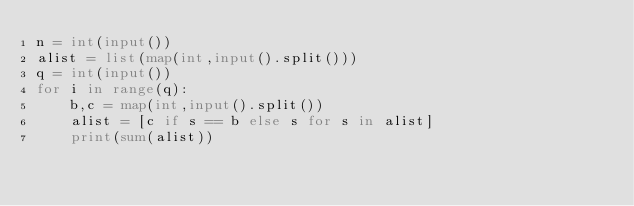Convert code to text. <code><loc_0><loc_0><loc_500><loc_500><_Python_>n = int(input())
alist = list(map(int,input().split()))
q = int(input())
for i in range(q):
    b,c = map(int,input().split())
    alist = [c if s == b else s for s in alist]
    print(sum(alist))</code> 